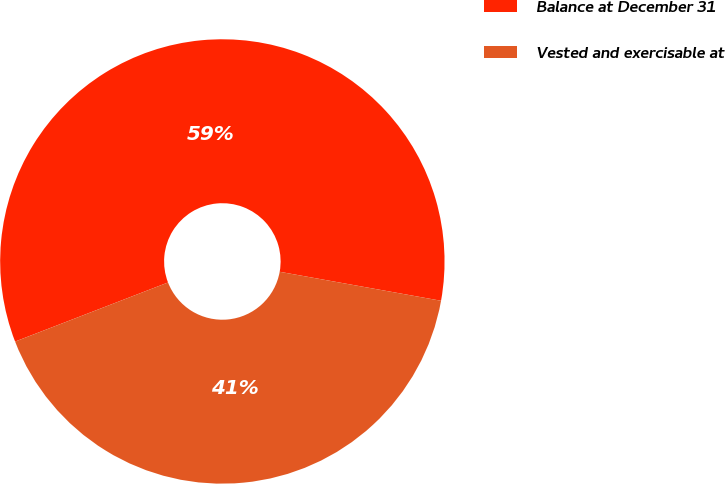Convert chart. <chart><loc_0><loc_0><loc_500><loc_500><pie_chart><fcel>Balance at December 31<fcel>Vested and exercisable at<nl><fcel>58.7%<fcel>41.3%<nl></chart> 